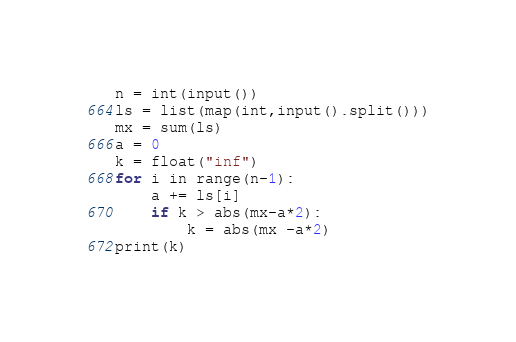<code> <loc_0><loc_0><loc_500><loc_500><_Python_>n = int(input())
ls = list(map(int,input().split()))
mx = sum(ls)
a = 0
k = float("inf")
for i in range(n-1):
    a += ls[i]
    if k > abs(mx-a*2):
        k = abs(mx -a*2)
print(k)
</code> 